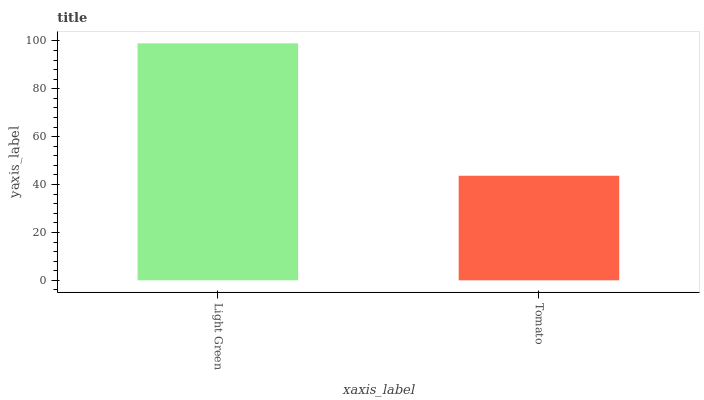Is Tomato the minimum?
Answer yes or no. Yes. Is Light Green the maximum?
Answer yes or no. Yes. Is Tomato the maximum?
Answer yes or no. No. Is Light Green greater than Tomato?
Answer yes or no. Yes. Is Tomato less than Light Green?
Answer yes or no. Yes. Is Tomato greater than Light Green?
Answer yes or no. No. Is Light Green less than Tomato?
Answer yes or no. No. Is Light Green the high median?
Answer yes or no. Yes. Is Tomato the low median?
Answer yes or no. Yes. Is Tomato the high median?
Answer yes or no. No. Is Light Green the low median?
Answer yes or no. No. 